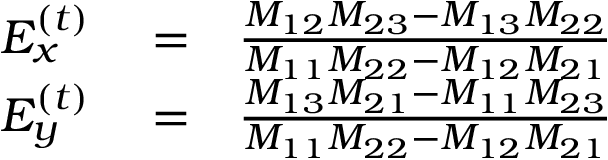<formula> <loc_0><loc_0><loc_500><loc_500>\begin{array} { r l r } { E _ { x } ^ { \left ( t \right ) } } & = } & { \frac { M _ { 1 2 } M _ { 2 3 } - M _ { 1 3 } M _ { 2 2 } } { M _ { 1 1 } M _ { 2 2 } - M _ { 1 2 } M _ { 2 1 } } } \\ { E _ { y } ^ { \left ( t \right ) } } & = } & { \frac { M _ { 1 3 } M _ { 2 1 } - M _ { 1 1 } M _ { 2 3 } } { M _ { 1 1 } M _ { 2 2 } - M _ { 1 2 } M _ { 2 1 } } } \end{array}</formula> 